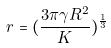Convert formula to latex. <formula><loc_0><loc_0><loc_500><loc_500>r = ( \frac { 3 \pi \gamma R ^ { 2 } } { K } ) ^ { \frac { 1 } { 3 } }</formula> 